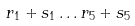<formula> <loc_0><loc_0><loc_500><loc_500>r _ { 1 } + s _ { 1 } \dots r _ { 5 } + s _ { 5 }</formula> 